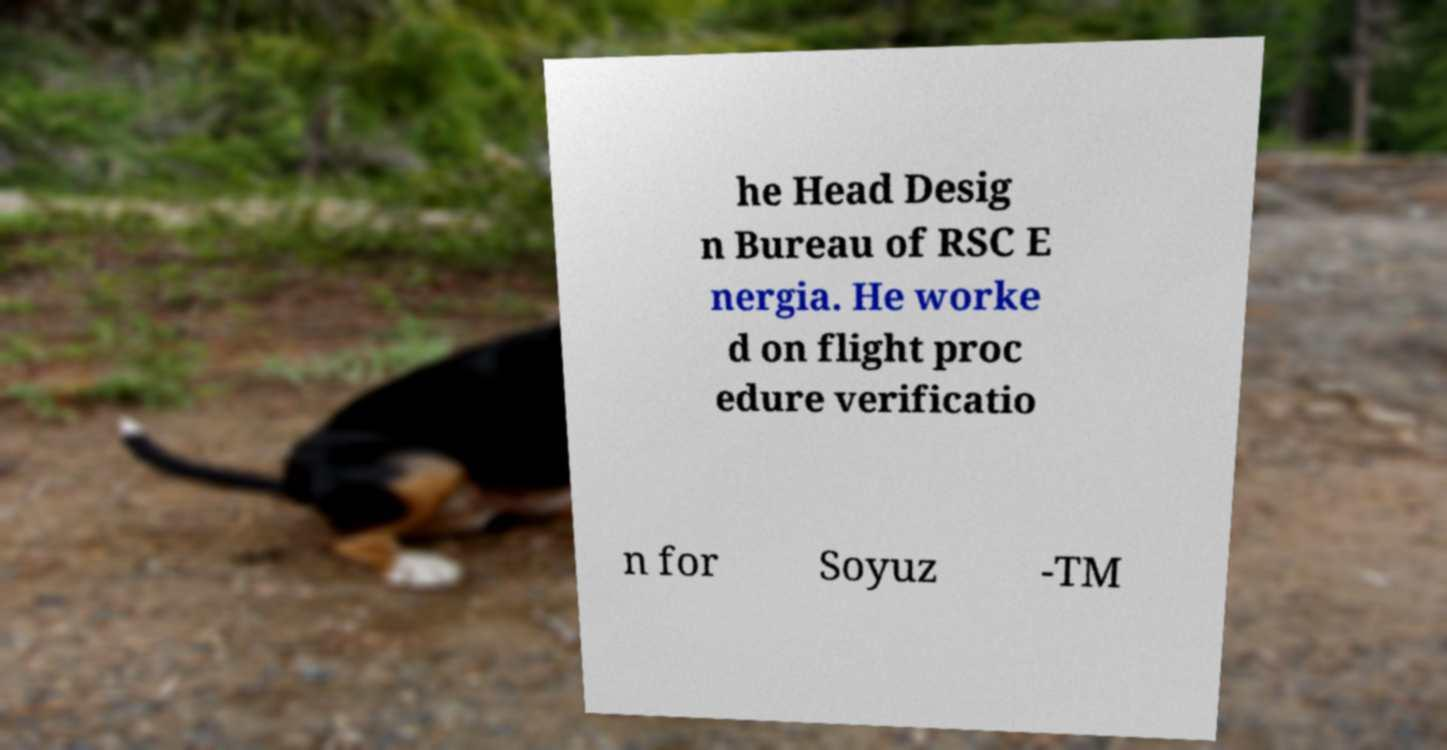Can you read and provide the text displayed in the image?This photo seems to have some interesting text. Can you extract and type it out for me? he Head Desig n Bureau of RSC E nergia. He worke d on flight proc edure verificatio n for Soyuz -TM 